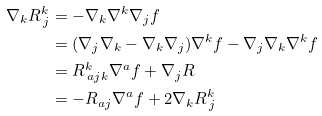Convert formula to latex. <formula><loc_0><loc_0><loc_500><loc_500>\nabla _ { k } R ^ { k } _ { \, j } & = - \nabla _ { k } \nabla ^ { k } \nabla _ { j } f \\ & = ( \nabla _ { j } \nabla _ { k } - \nabla _ { k } \nabla _ { j } ) \nabla ^ { k } f - \nabla _ { j } \nabla _ { k } \nabla ^ { k } f \\ & = R ^ { k } _ { \, a j k } \nabla ^ { a } f + \nabla _ { j } R \\ & = - R _ { a j } \nabla ^ { a } f + 2 \nabla _ { k } R ^ { k } _ { \, j }</formula> 